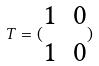<formula> <loc_0><loc_0><loc_500><loc_500>T = ( \begin{matrix} 1 & 0 \\ 1 & 0 \end{matrix} )</formula> 